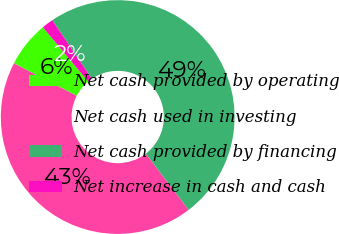Convert chart. <chart><loc_0><loc_0><loc_500><loc_500><pie_chart><fcel>Net cash provided by operating<fcel>Net cash used in investing<fcel>Net cash provided by financing<fcel>Net increase in cash and cash<nl><fcel>6.34%<fcel>42.99%<fcel>49.07%<fcel>1.6%<nl></chart> 